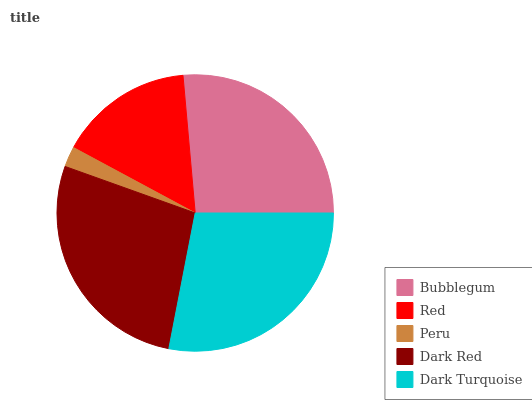Is Peru the minimum?
Answer yes or no. Yes. Is Dark Turquoise the maximum?
Answer yes or no. Yes. Is Red the minimum?
Answer yes or no. No. Is Red the maximum?
Answer yes or no. No. Is Bubblegum greater than Red?
Answer yes or no. Yes. Is Red less than Bubblegum?
Answer yes or no. Yes. Is Red greater than Bubblegum?
Answer yes or no. No. Is Bubblegum less than Red?
Answer yes or no. No. Is Bubblegum the high median?
Answer yes or no. Yes. Is Bubblegum the low median?
Answer yes or no. Yes. Is Peru the high median?
Answer yes or no. No. Is Dark Red the low median?
Answer yes or no. No. 